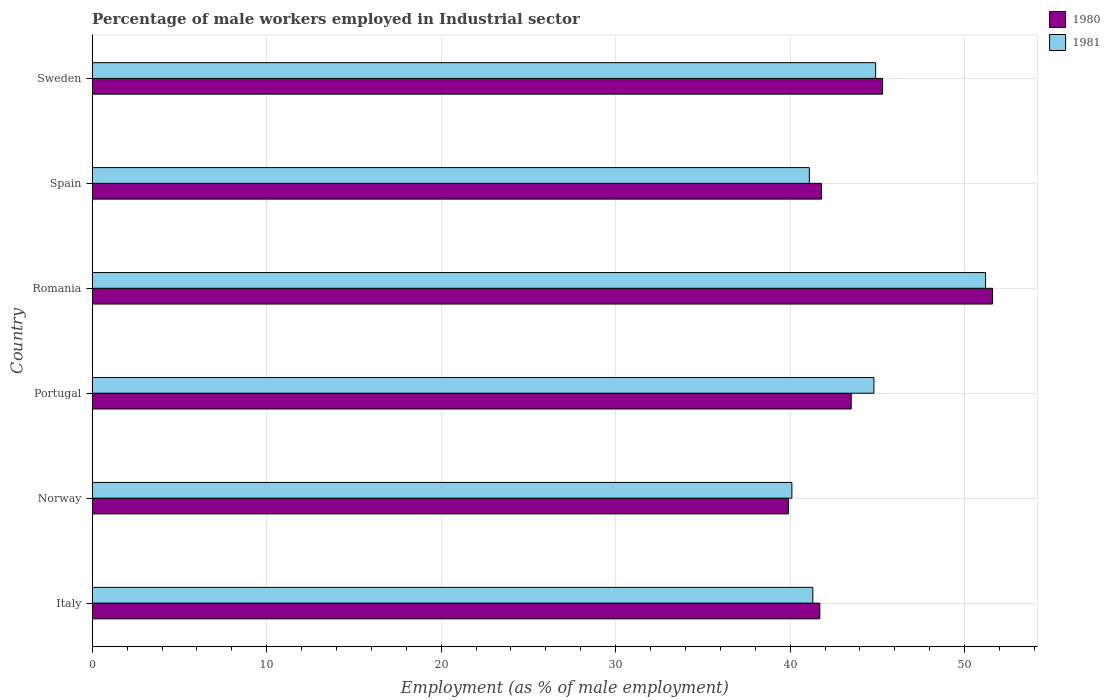How many different coloured bars are there?
Your answer should be compact. 2. Are the number of bars per tick equal to the number of legend labels?
Give a very brief answer. Yes. Are the number of bars on each tick of the Y-axis equal?
Keep it short and to the point. Yes. How many bars are there on the 1st tick from the bottom?
Your answer should be compact. 2. In how many cases, is the number of bars for a given country not equal to the number of legend labels?
Ensure brevity in your answer.  0. What is the percentage of male workers employed in Industrial sector in 1980 in Portugal?
Give a very brief answer. 43.5. Across all countries, what is the maximum percentage of male workers employed in Industrial sector in 1980?
Your response must be concise. 51.6. Across all countries, what is the minimum percentage of male workers employed in Industrial sector in 1980?
Your answer should be very brief. 39.9. In which country was the percentage of male workers employed in Industrial sector in 1980 maximum?
Make the answer very short. Romania. In which country was the percentage of male workers employed in Industrial sector in 1981 minimum?
Keep it short and to the point. Norway. What is the total percentage of male workers employed in Industrial sector in 1980 in the graph?
Give a very brief answer. 263.8. What is the difference between the percentage of male workers employed in Industrial sector in 1980 in Norway and that in Portugal?
Keep it short and to the point. -3.6. What is the difference between the percentage of male workers employed in Industrial sector in 1980 in Portugal and the percentage of male workers employed in Industrial sector in 1981 in Romania?
Ensure brevity in your answer.  -7.7. What is the average percentage of male workers employed in Industrial sector in 1980 per country?
Your answer should be very brief. 43.97. What is the difference between the percentage of male workers employed in Industrial sector in 1980 and percentage of male workers employed in Industrial sector in 1981 in Portugal?
Your answer should be very brief. -1.3. What is the ratio of the percentage of male workers employed in Industrial sector in 1981 in Spain to that in Sweden?
Provide a short and direct response. 0.92. What is the difference between the highest and the second highest percentage of male workers employed in Industrial sector in 1980?
Ensure brevity in your answer.  6.3. What is the difference between the highest and the lowest percentage of male workers employed in Industrial sector in 1981?
Provide a succinct answer. 11.1. In how many countries, is the percentage of male workers employed in Industrial sector in 1980 greater than the average percentage of male workers employed in Industrial sector in 1980 taken over all countries?
Your response must be concise. 2. How many bars are there?
Offer a very short reply. 12. Are all the bars in the graph horizontal?
Make the answer very short. Yes. What is the difference between two consecutive major ticks on the X-axis?
Provide a succinct answer. 10. Are the values on the major ticks of X-axis written in scientific E-notation?
Provide a short and direct response. No. Does the graph contain any zero values?
Give a very brief answer. No. Does the graph contain grids?
Ensure brevity in your answer.  Yes. Where does the legend appear in the graph?
Make the answer very short. Top right. How many legend labels are there?
Give a very brief answer. 2. What is the title of the graph?
Your answer should be compact. Percentage of male workers employed in Industrial sector. What is the label or title of the X-axis?
Ensure brevity in your answer.  Employment (as % of male employment). What is the Employment (as % of male employment) of 1980 in Italy?
Your answer should be very brief. 41.7. What is the Employment (as % of male employment) in 1981 in Italy?
Offer a very short reply. 41.3. What is the Employment (as % of male employment) in 1980 in Norway?
Give a very brief answer. 39.9. What is the Employment (as % of male employment) of 1981 in Norway?
Ensure brevity in your answer.  40.1. What is the Employment (as % of male employment) of 1980 in Portugal?
Offer a terse response. 43.5. What is the Employment (as % of male employment) in 1981 in Portugal?
Keep it short and to the point. 44.8. What is the Employment (as % of male employment) of 1980 in Romania?
Provide a short and direct response. 51.6. What is the Employment (as % of male employment) of 1981 in Romania?
Your answer should be compact. 51.2. What is the Employment (as % of male employment) of 1980 in Spain?
Your answer should be compact. 41.8. What is the Employment (as % of male employment) in 1981 in Spain?
Your response must be concise. 41.1. What is the Employment (as % of male employment) of 1980 in Sweden?
Keep it short and to the point. 45.3. What is the Employment (as % of male employment) in 1981 in Sweden?
Give a very brief answer. 44.9. Across all countries, what is the maximum Employment (as % of male employment) of 1980?
Offer a very short reply. 51.6. Across all countries, what is the maximum Employment (as % of male employment) in 1981?
Your response must be concise. 51.2. Across all countries, what is the minimum Employment (as % of male employment) of 1980?
Provide a succinct answer. 39.9. Across all countries, what is the minimum Employment (as % of male employment) in 1981?
Your answer should be compact. 40.1. What is the total Employment (as % of male employment) in 1980 in the graph?
Your answer should be very brief. 263.8. What is the total Employment (as % of male employment) of 1981 in the graph?
Provide a succinct answer. 263.4. What is the difference between the Employment (as % of male employment) in 1981 in Italy and that in Portugal?
Provide a short and direct response. -3.5. What is the difference between the Employment (as % of male employment) in 1980 in Italy and that in Romania?
Make the answer very short. -9.9. What is the difference between the Employment (as % of male employment) in 1980 in Italy and that in Spain?
Offer a terse response. -0.1. What is the difference between the Employment (as % of male employment) of 1981 in Italy and that in Spain?
Make the answer very short. 0.2. What is the difference between the Employment (as % of male employment) in 1980 in Italy and that in Sweden?
Provide a short and direct response. -3.6. What is the difference between the Employment (as % of male employment) in 1981 in Italy and that in Sweden?
Your answer should be very brief. -3.6. What is the difference between the Employment (as % of male employment) of 1980 in Norway and that in Portugal?
Keep it short and to the point. -3.6. What is the difference between the Employment (as % of male employment) in 1981 in Norway and that in Portugal?
Give a very brief answer. -4.7. What is the difference between the Employment (as % of male employment) of 1980 in Norway and that in Romania?
Give a very brief answer. -11.7. What is the difference between the Employment (as % of male employment) in 1980 in Norway and that in Spain?
Your response must be concise. -1.9. What is the difference between the Employment (as % of male employment) of 1980 in Portugal and that in Romania?
Keep it short and to the point. -8.1. What is the difference between the Employment (as % of male employment) in 1980 in Portugal and that in Spain?
Provide a succinct answer. 1.7. What is the difference between the Employment (as % of male employment) of 1981 in Portugal and that in Sweden?
Offer a terse response. -0.1. What is the difference between the Employment (as % of male employment) of 1981 in Romania and that in Spain?
Provide a succinct answer. 10.1. What is the difference between the Employment (as % of male employment) of 1980 in Italy and the Employment (as % of male employment) of 1981 in Portugal?
Your answer should be compact. -3.1. What is the difference between the Employment (as % of male employment) of 1980 in Italy and the Employment (as % of male employment) of 1981 in Romania?
Offer a very short reply. -9.5. What is the difference between the Employment (as % of male employment) of 1980 in Italy and the Employment (as % of male employment) of 1981 in Sweden?
Provide a succinct answer. -3.2. What is the difference between the Employment (as % of male employment) in 1980 in Portugal and the Employment (as % of male employment) in 1981 in Romania?
Keep it short and to the point. -7.7. What is the difference between the Employment (as % of male employment) in 1980 in Portugal and the Employment (as % of male employment) in 1981 in Spain?
Offer a terse response. 2.4. What is the difference between the Employment (as % of male employment) of 1980 in Romania and the Employment (as % of male employment) of 1981 in Sweden?
Keep it short and to the point. 6.7. What is the average Employment (as % of male employment) in 1980 per country?
Offer a terse response. 43.97. What is the average Employment (as % of male employment) in 1981 per country?
Provide a succinct answer. 43.9. What is the ratio of the Employment (as % of male employment) of 1980 in Italy to that in Norway?
Keep it short and to the point. 1.05. What is the ratio of the Employment (as % of male employment) of 1981 in Italy to that in Norway?
Provide a succinct answer. 1.03. What is the ratio of the Employment (as % of male employment) of 1980 in Italy to that in Portugal?
Give a very brief answer. 0.96. What is the ratio of the Employment (as % of male employment) of 1981 in Italy to that in Portugal?
Make the answer very short. 0.92. What is the ratio of the Employment (as % of male employment) in 1980 in Italy to that in Romania?
Your answer should be compact. 0.81. What is the ratio of the Employment (as % of male employment) in 1981 in Italy to that in Romania?
Your response must be concise. 0.81. What is the ratio of the Employment (as % of male employment) in 1980 in Italy to that in Spain?
Make the answer very short. 1. What is the ratio of the Employment (as % of male employment) of 1981 in Italy to that in Spain?
Your response must be concise. 1. What is the ratio of the Employment (as % of male employment) of 1980 in Italy to that in Sweden?
Offer a very short reply. 0.92. What is the ratio of the Employment (as % of male employment) of 1981 in Italy to that in Sweden?
Your answer should be compact. 0.92. What is the ratio of the Employment (as % of male employment) in 1980 in Norway to that in Portugal?
Your answer should be very brief. 0.92. What is the ratio of the Employment (as % of male employment) in 1981 in Norway to that in Portugal?
Provide a short and direct response. 0.9. What is the ratio of the Employment (as % of male employment) in 1980 in Norway to that in Romania?
Your answer should be very brief. 0.77. What is the ratio of the Employment (as % of male employment) of 1981 in Norway to that in Romania?
Keep it short and to the point. 0.78. What is the ratio of the Employment (as % of male employment) of 1980 in Norway to that in Spain?
Offer a terse response. 0.95. What is the ratio of the Employment (as % of male employment) of 1981 in Norway to that in Spain?
Keep it short and to the point. 0.98. What is the ratio of the Employment (as % of male employment) of 1980 in Norway to that in Sweden?
Your response must be concise. 0.88. What is the ratio of the Employment (as % of male employment) in 1981 in Norway to that in Sweden?
Your response must be concise. 0.89. What is the ratio of the Employment (as % of male employment) in 1980 in Portugal to that in Romania?
Your response must be concise. 0.84. What is the ratio of the Employment (as % of male employment) of 1981 in Portugal to that in Romania?
Offer a terse response. 0.88. What is the ratio of the Employment (as % of male employment) of 1980 in Portugal to that in Spain?
Give a very brief answer. 1.04. What is the ratio of the Employment (as % of male employment) in 1981 in Portugal to that in Spain?
Make the answer very short. 1.09. What is the ratio of the Employment (as % of male employment) of 1980 in Portugal to that in Sweden?
Ensure brevity in your answer.  0.96. What is the ratio of the Employment (as % of male employment) of 1980 in Romania to that in Spain?
Offer a terse response. 1.23. What is the ratio of the Employment (as % of male employment) in 1981 in Romania to that in Spain?
Make the answer very short. 1.25. What is the ratio of the Employment (as % of male employment) in 1980 in Romania to that in Sweden?
Your response must be concise. 1.14. What is the ratio of the Employment (as % of male employment) in 1981 in Romania to that in Sweden?
Provide a succinct answer. 1.14. What is the ratio of the Employment (as % of male employment) in 1980 in Spain to that in Sweden?
Ensure brevity in your answer.  0.92. What is the ratio of the Employment (as % of male employment) of 1981 in Spain to that in Sweden?
Provide a succinct answer. 0.92. What is the difference between the highest and the second highest Employment (as % of male employment) in 1980?
Your response must be concise. 6.3. What is the difference between the highest and the second highest Employment (as % of male employment) of 1981?
Provide a short and direct response. 6.3. 